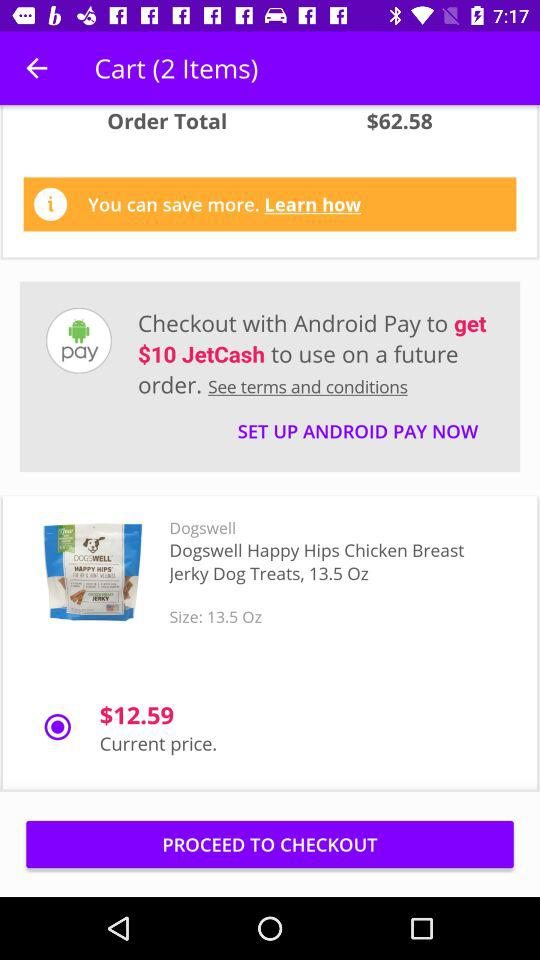What is the number of items in the cart? There are 2 items. 